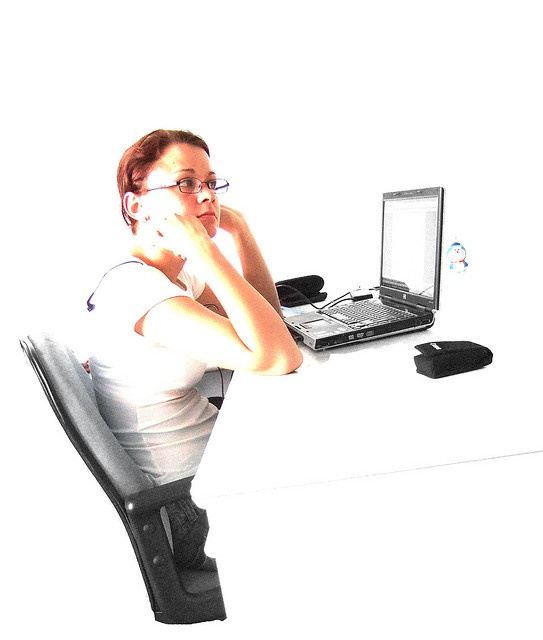Describe the objects in this image and their specific colors. I can see people in white, salmon, and tan tones, chair in white, black, gray, darkgray, and lightgray tones, and laptop in white, darkgray, gray, and black tones in this image. 